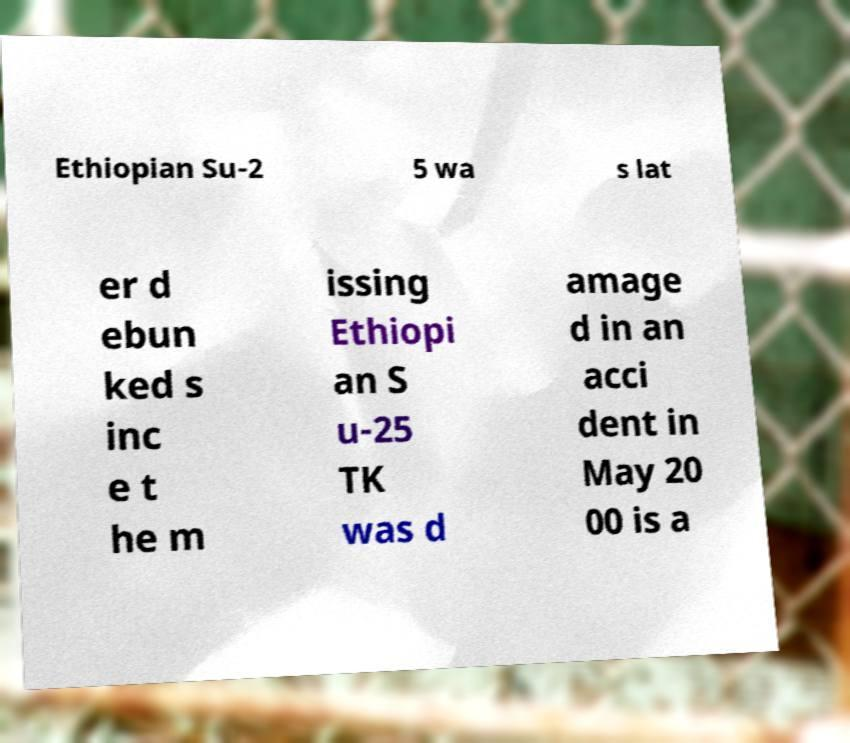I need the written content from this picture converted into text. Can you do that? Ethiopian Su-2 5 wa s lat er d ebun ked s inc e t he m issing Ethiopi an S u-25 TK was d amage d in an acci dent in May 20 00 is a 